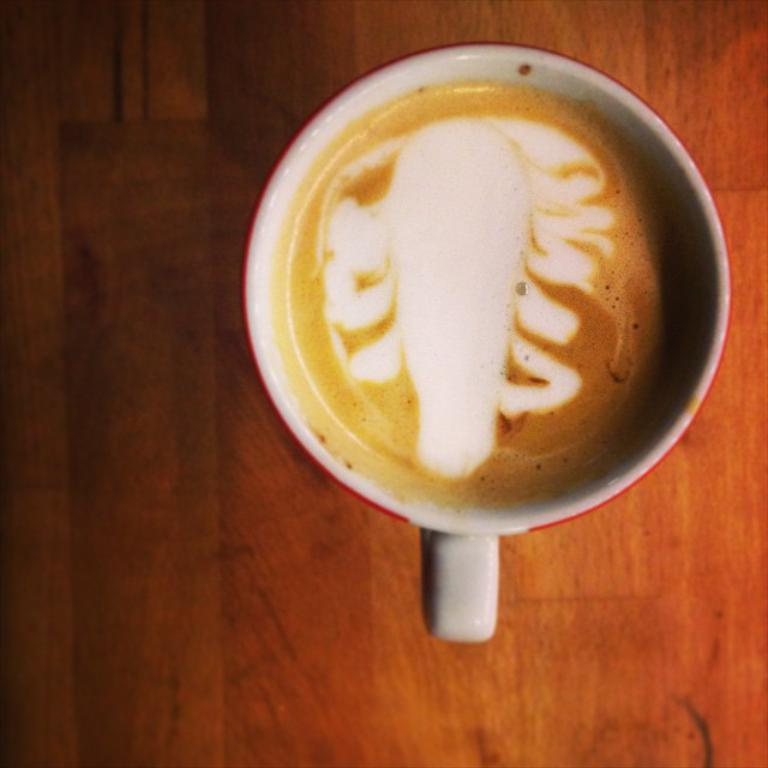What is in the cup that is visible in the image? The cup contains some liquid. What type of surface is the cup placed on in the image? The wooden surface is present in the image. How does the cup contribute to the destruction of the wooden surface in the image? The cup does not contribute to the destruction of the wooden surface in the image; it is simply placed on the wooden surface. 